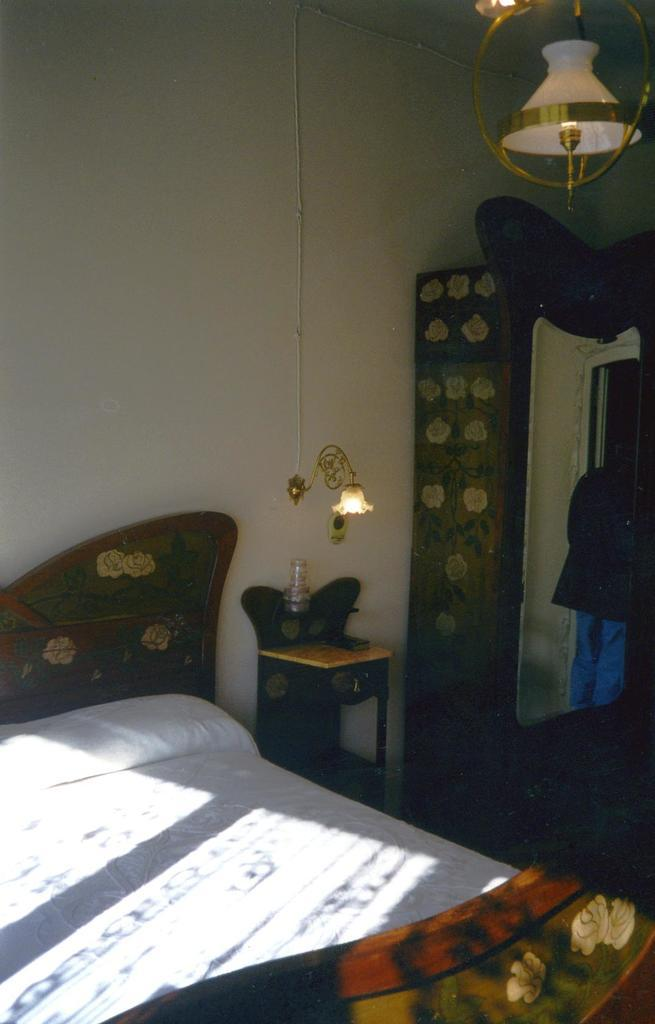What type of furniture is present in the image? There is a bed in the image. What is another object visible in the image? There is a lamp in the image. What can be used for personal grooming or checking one's appearance in the image? There is a mirror in the image. What language is spoken by the bed in the image? The bed does not speak a language, as it is an inanimate object. 